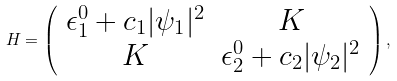Convert formula to latex. <formula><loc_0><loc_0><loc_500><loc_500>H = \left ( \begin{array} { c c } \epsilon ^ { 0 } _ { 1 } + c _ { 1 } | \psi _ { 1 } | ^ { 2 } & K \\ K & \epsilon ^ { 0 } _ { 2 } + c _ { 2 } | \psi _ { 2 } | ^ { 2 } \\ \end{array} \right ) ,</formula> 